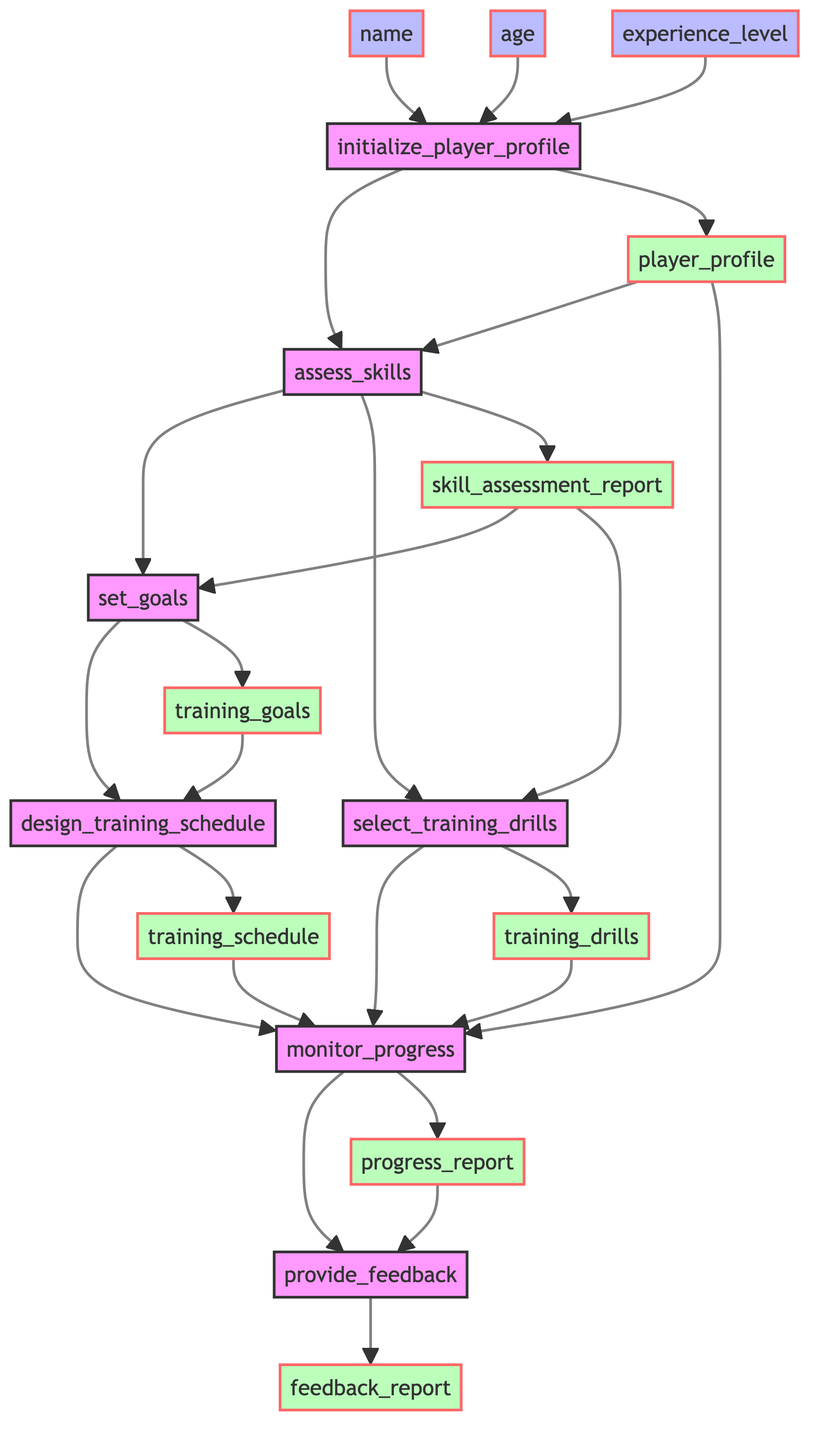what is the first step in the flowchart? The first step in the flowchart is "initialize_player_profile," which is the starting point for creating a player's profile.
Answer: initialize_player_profile how many steps are there in total? There are seven steps in the flowchart. They are: initialize_player_profile, assess_skills, set_goals, design_training_schedule, select_training_drills, monitor_progress, and provide_feedback.
Answer: seven what is the output of the assess_skills step? The output of the assess_skills step is "skill_assessment_report." This report conveys the results of evaluating the player's skills.
Answer: skill_assessment_report which steps have a direct input from skill_assessment_report? The steps that directly receive the output from skill_assessment_report are "set_goals" and "select_training_drills." Both of these steps rely on the skill assessment to proceed.
Answer: set_goals, select_training_drills what are the inputs required for the initialize_player_profile step? The inputs required for the initialize_player_profile step are "name," "age," and "experience_level." These details are needed to create a player profile.
Answer: name, age, experience_level what common output do the design_training_schedule and select_training_drills steps feed into? Both the design_training_schedule and select_training_drills steps feed their outputs into the "monitor_progress" step. This shows that the results from both training aspects are combined for progress evaluation.
Answer: monitor_progress what feedback is provided after monitoring progress? The feedback provided after monitoring progress is outlined in the "feedback_report." This report serves to give the player constructive feedback based on their progress.
Answer: feedback_report what happens if inputs to the monitor_progress step are missing? If the inputs to the monitor_progress step are missing, it would not function correctly since it relies on player_profile, training_schedule, and training_drills to assess and adjust the training program.
Answer: it cannot function correctly 